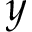<formula> <loc_0><loc_0><loc_500><loc_500>y</formula> 